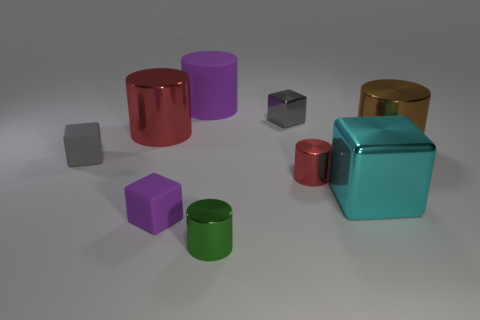Is there any other thing that has the same material as the small red object?
Keep it short and to the point. Yes. There is a small matte object that is the same color as the big matte cylinder; what is its shape?
Your answer should be compact. Cube. The matte thing that is the same size as the brown cylinder is what color?
Make the answer very short. Purple. Are there any big metallic things that have the same color as the large rubber cylinder?
Make the answer very short. No. How many objects are either tiny things that are in front of the large red metallic object or small gray rubber objects?
Ensure brevity in your answer.  4. How many other things are the same size as the cyan object?
Provide a short and direct response. 3. There is a red object in front of the large metallic object on the left side of the red shiny object that is right of the big rubber cylinder; what is its material?
Offer a terse response. Metal. How many cylinders are small things or metal objects?
Make the answer very short. 4. Are there any other things that are the same shape as the tiny gray rubber thing?
Give a very brief answer. Yes. Is the number of gray rubber things that are on the right side of the large brown shiny cylinder greater than the number of tiny green shiny objects that are right of the big cyan thing?
Your answer should be very brief. No. 